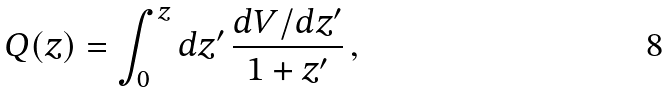Convert formula to latex. <formula><loc_0><loc_0><loc_500><loc_500>Q ( z ) = \int _ { 0 } ^ { z } d z ^ { \prime } \, \frac { d V / d z ^ { \prime } } { 1 + z ^ { \prime } } \, ,</formula> 